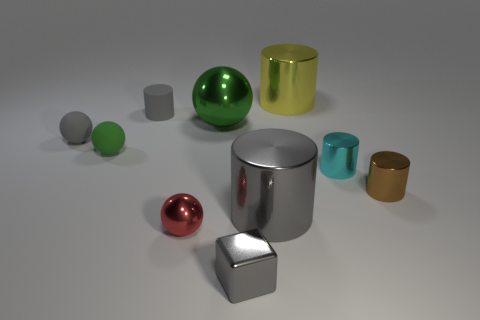How many gray cylinders must be subtracted to get 1 gray cylinders? 1 Subtract all tiny red metal spheres. How many spheres are left? 3 Subtract all cyan cylinders. How many cylinders are left? 4 Subtract 0 brown spheres. How many objects are left? 10 Subtract all cubes. How many objects are left? 9 Subtract 3 spheres. How many spheres are left? 1 Subtract all yellow blocks. Subtract all yellow balls. How many blocks are left? 1 Subtract all blue spheres. How many green cylinders are left? 0 Subtract all gray balls. Subtract all gray cubes. How many objects are left? 8 Add 9 tiny red objects. How many tiny red objects are left? 10 